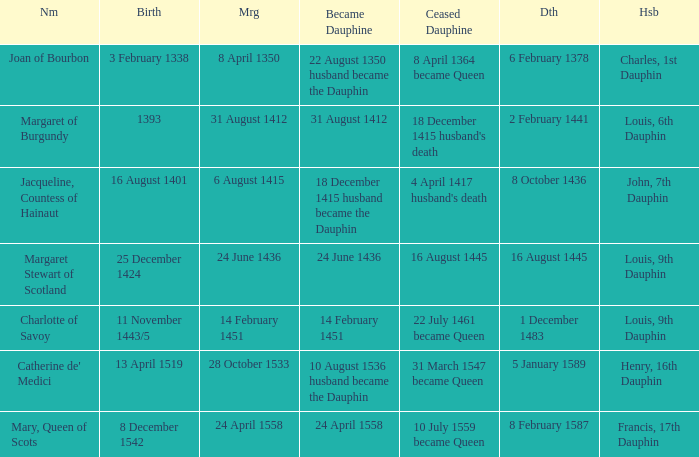Can you give me this table as a dict? {'header': ['Nm', 'Birth', 'Mrg', 'Became Dauphine', 'Ceased Dauphine', 'Dth', 'Hsb'], 'rows': [['Joan of Bourbon', '3 February 1338', '8 April 1350', '22 August 1350 husband became the Dauphin', '8 April 1364 became Queen', '6 February 1378', 'Charles, 1st Dauphin'], ['Margaret of Burgundy', '1393', '31 August 1412', '31 August 1412', "18 December 1415 husband's death", '2 February 1441', 'Louis, 6th Dauphin'], ['Jacqueline, Countess of Hainaut', '16 August 1401', '6 August 1415', '18 December 1415 husband became the Dauphin', "4 April 1417 husband's death", '8 October 1436', 'John, 7th Dauphin'], ['Margaret Stewart of Scotland', '25 December 1424', '24 June 1436', '24 June 1436', '16 August 1445', '16 August 1445', 'Louis, 9th Dauphin'], ['Charlotte of Savoy', '11 November 1443/5', '14 February 1451', '14 February 1451', '22 July 1461 became Queen', '1 December 1483', 'Louis, 9th Dauphin'], ["Catherine de' Medici", '13 April 1519', '28 October 1533', '10 August 1536 husband became the Dauphin', '31 March 1547 became Queen', '5 January 1589', 'Henry, 16th Dauphin'], ['Mary, Queen of Scots', '8 December 1542', '24 April 1558', '24 April 1558', '10 July 1559 became Queen', '8 February 1587', 'Francis, 17th Dauphin']]} Who is the husband when ceased to be dauphine is 22 july 1461 became queen? Louis, 9th Dauphin. 